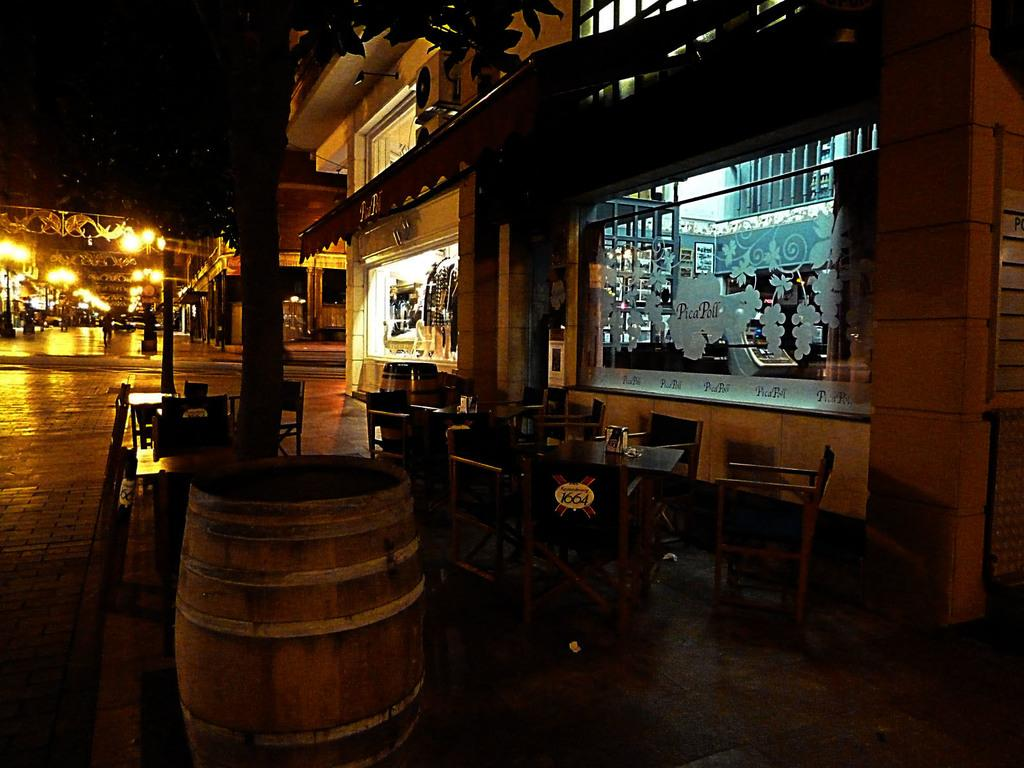What type of furniture is present in the image? There is a table and chairs in the image. Where are the table and chairs located? The table and chairs are on the ground. What else can be seen in the image besides the furniture? There is a building, a tree, and lights in the image. Is there a beggar sitting under the tree in the image? There is no beggar present in the image; it only features a table, chairs, a building, a tree, and lights. 